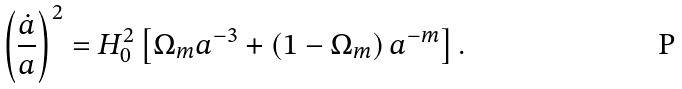<formula> <loc_0><loc_0><loc_500><loc_500>\left ( \frac { \dot { a } } { a } \right ) ^ { 2 } = H _ { 0 } ^ { 2 } \left [ \Omega _ { m } a ^ { - 3 } + \left ( 1 - \Omega _ { m } \right ) a ^ { - m } \right ] .</formula> 